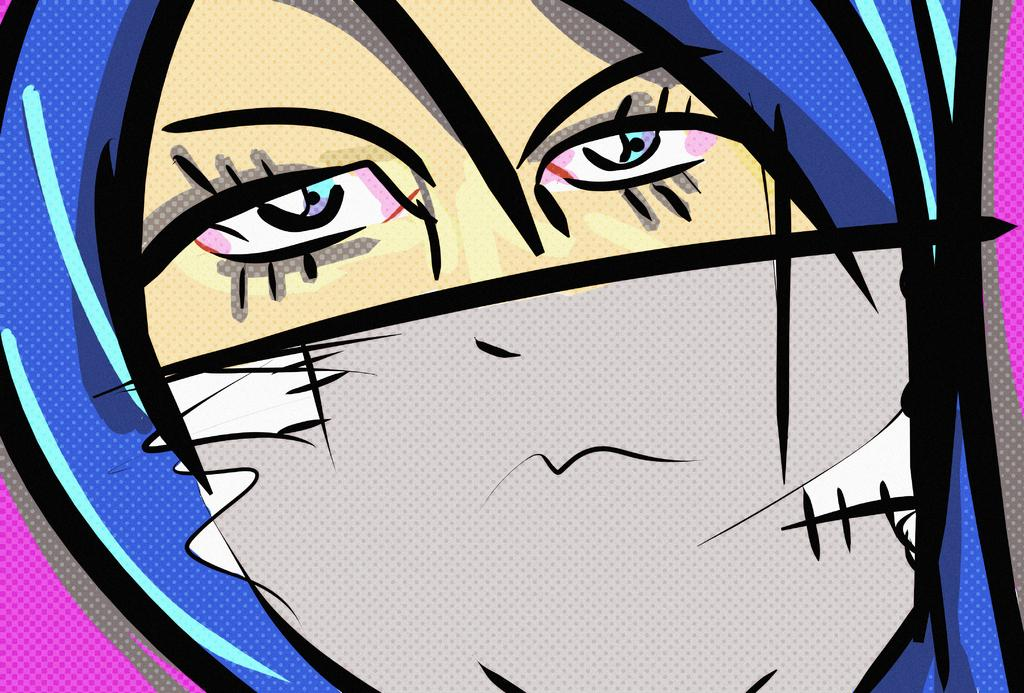What type of image is present in the picture? There is a cartoon picture of a person's face in the image. Can you describe the colors used in the cartoon picture? The cartoon picture has different colors. Is there any toothpaste visible in the image? There is no toothpaste present in the image. Is the cartoon picture hanging on a wall in the image? The provided facts do not mention a wall or any other context for the cartoon picture, so it cannot be determined if it is hanging on a wall. 